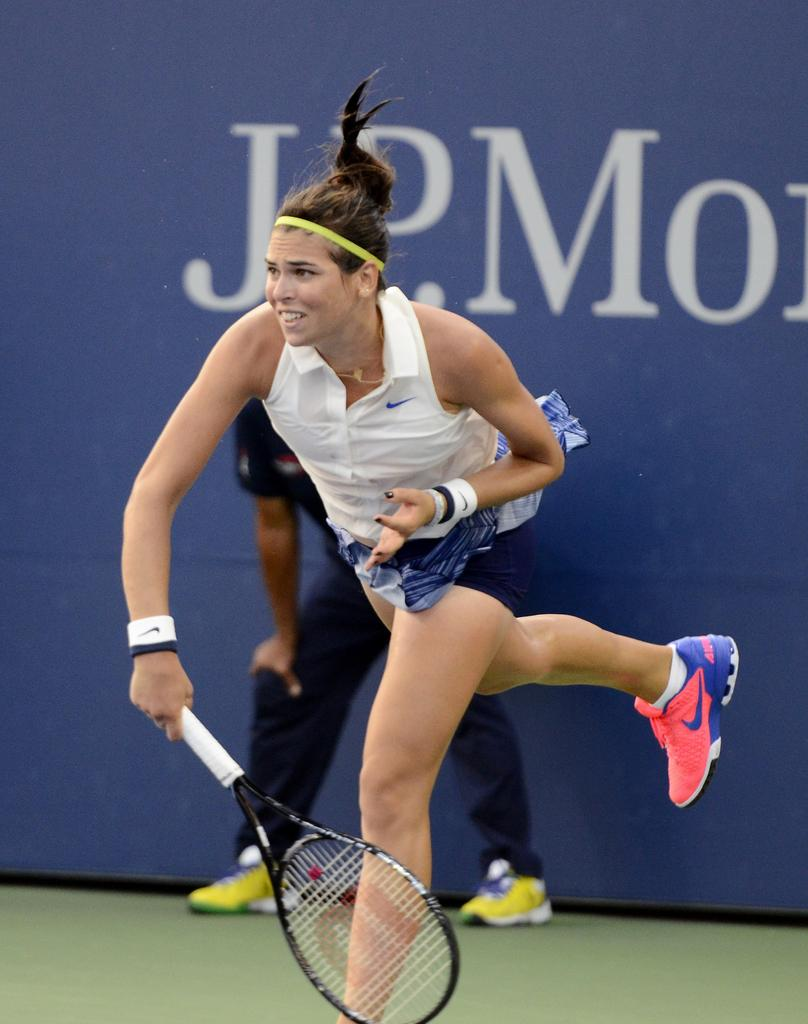Who is the main subject in the image? There is a woman in the image. What is the woman holding in the image? The woman is holding a tennis bat. Can you describe the other person in the image? There is another person in the image, behind the woman. What type of berry can be seen growing on the roof in the image? There is no roof or berry present in the image. 